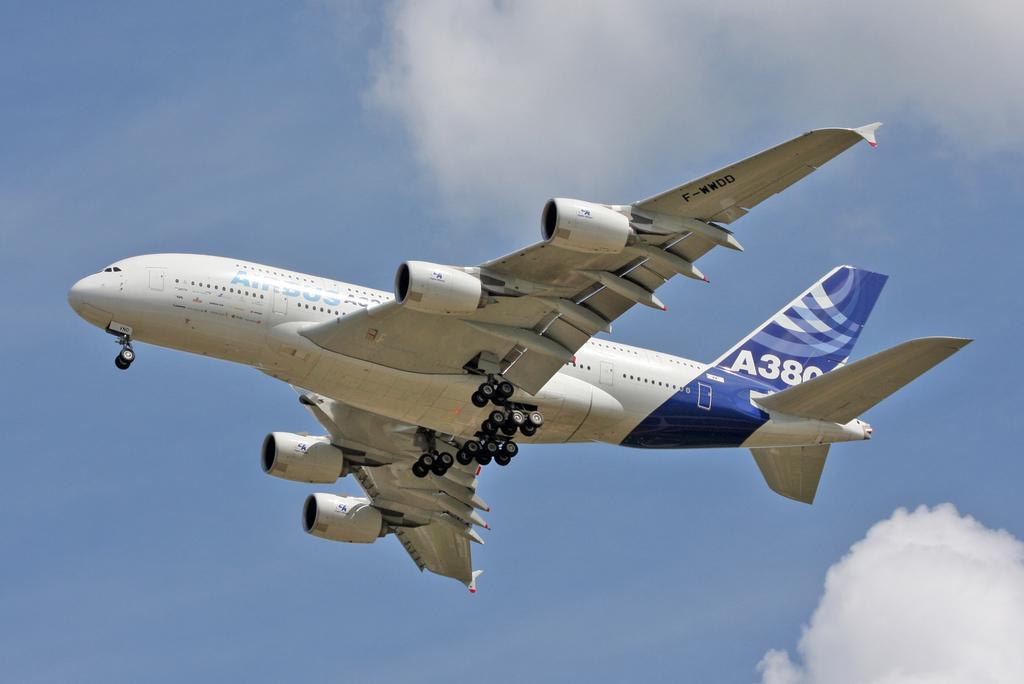<image>
Give a short and clear explanation of the subsequent image. A380 passenger jet flies overhead against the blue sky back drop. 